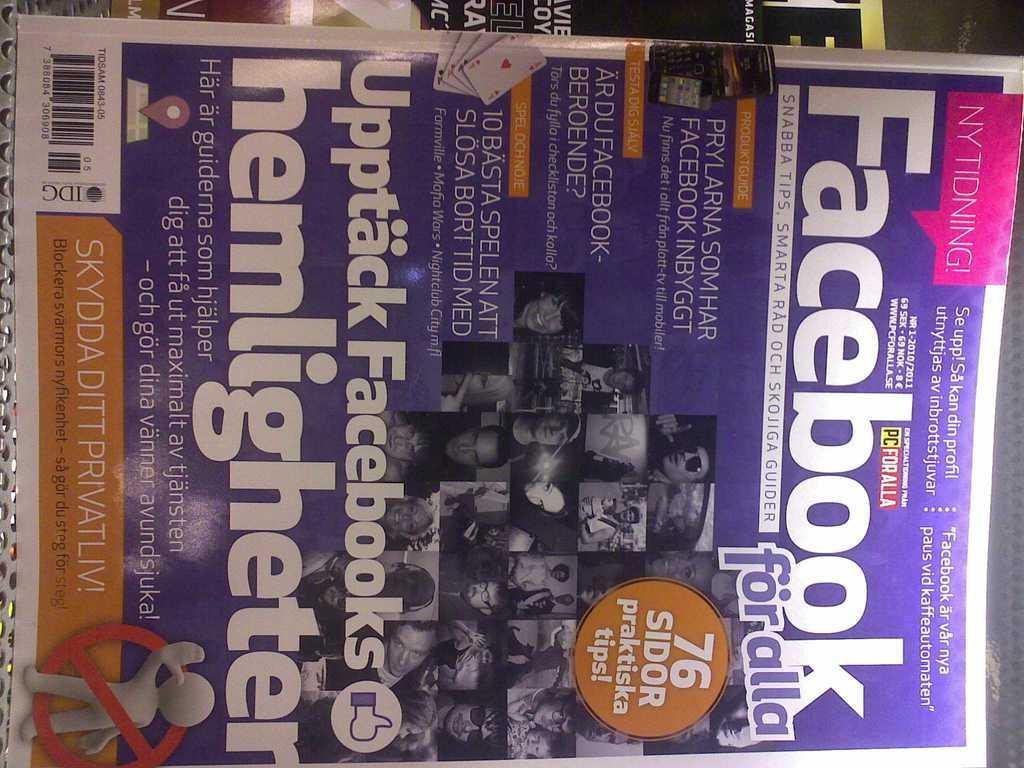<image>
Relay a brief, clear account of the picture shown. a magazine that says 'facebook' in bold white letters on it 